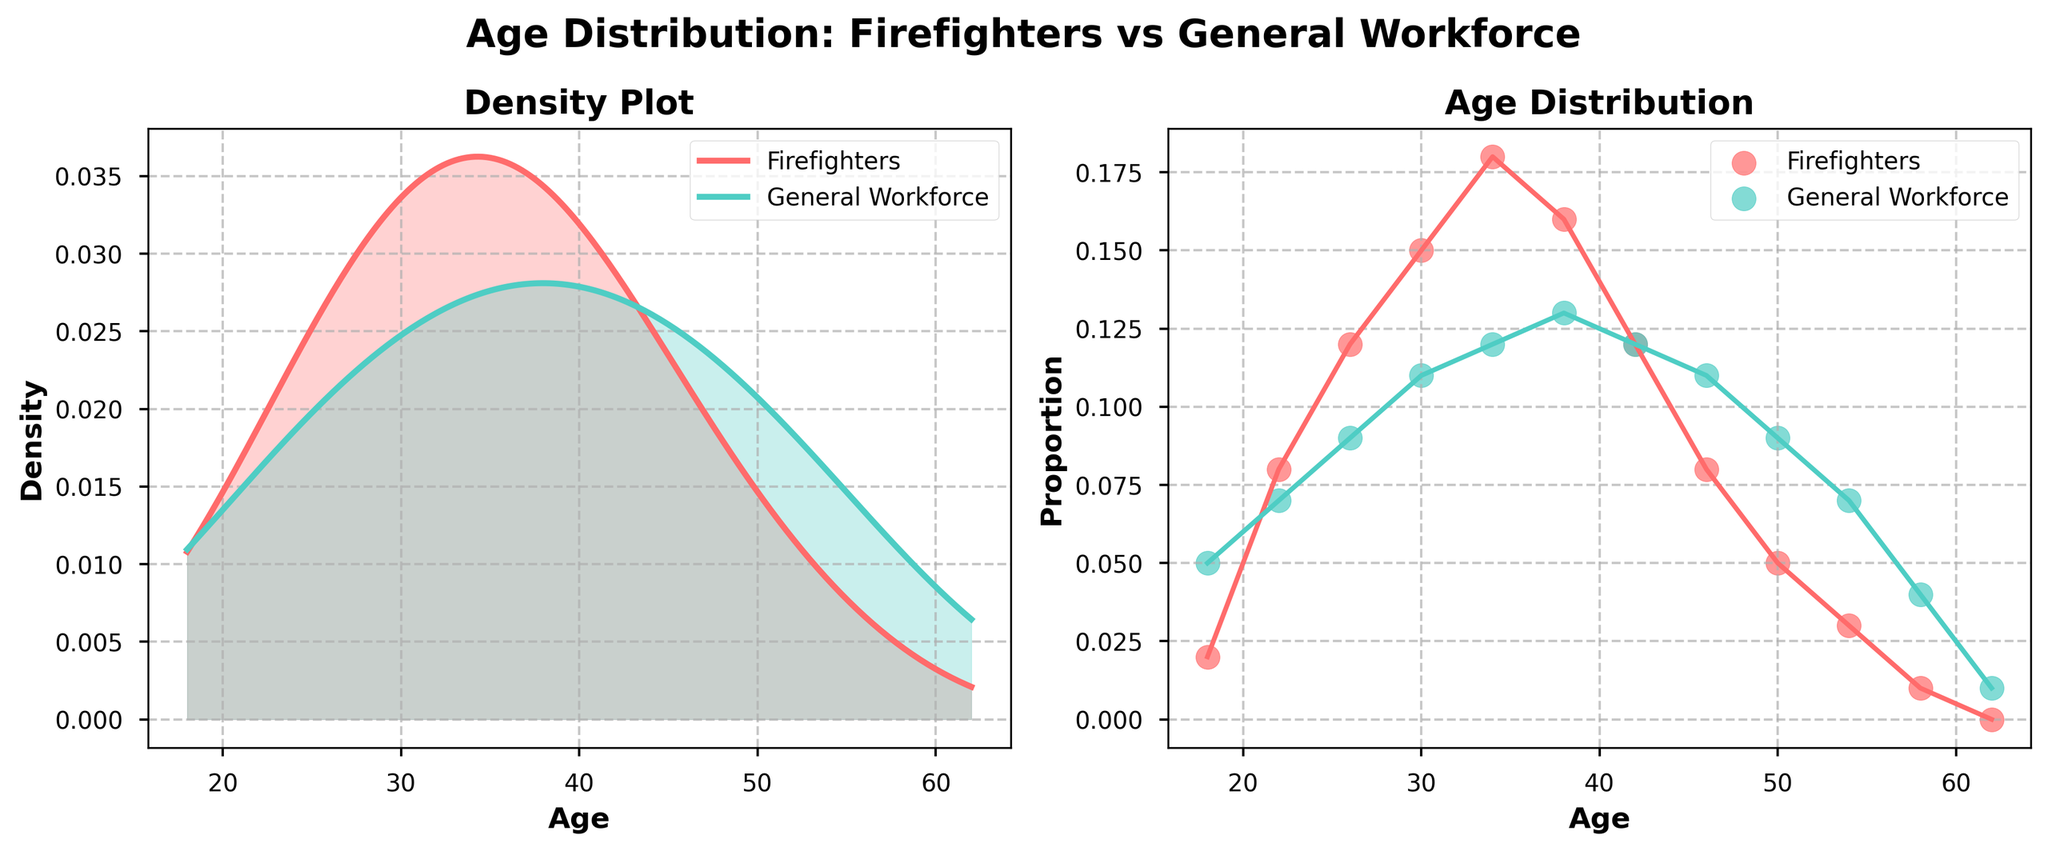what are the titles of the two subplots? The titles are located above each subplot. For the left subplot, look above the graph for the text, and for the right subplot, similarly look above the graph. First subplot title is "Density Plot". The second subplot title is "Age Distribution".
Answer: Density Plot and Age Distribution what is the age range covered by the plots? Check the x-axis of the plots. It shows the starting and ending age values. The age range starts at 18 and ends at 62, as indicated on the x-axis.
Answer: 18 to 62 which group shows a higher peak density in the density plot? Look at the height of the peaks in the left subplot. Compare both colored lines: the red line (Firefighters) and the teal line (General Workforce). The Firefighters line has the higher peak.
Answer: Firefighters how does the density of the general workforce change after age 38? In the left subplot, follow the teal line (General Workforce) from age 38 onwards. Observe if it rises or falls. The line starts to decline after age 38.
Answer: It decreases at what age is the proportion of firefighters equal to the proportion of the general workforce? In the right subplot, find where the red and teal points are at the same height (same proportion). This happens at age 42.
Answer: 42 which group has more representation at age 26? In the right subplot, compare the vertical positions of points for Firefighters and General Workforce at age 26. The red point (Firefighters) is higher than the teal point (General Workforce).
Answer: Firefighters how do the patterns in age distribution for firefighters compare to the general workforce? Observe both subplots for similarities and differences in the curves and dots. The Firefighters have a peak at a younger age compared to the General Workforce and then declines more rapidly as age increases.
Answer: Higher peak at younger ages and rapid decline for Firefighters what is the trend in the density of firefighters after age 34? Check the left subplot after age 34 and follow the red line (Firefighters) to see if it rises, stays flat, or falls. The density starts to fall after age 34.
Answer: It decreases what visual cues indicate differences between the two groups in the density plot? Identify different visual aspects such as line color, line height (density), and shaded areas in the left subplot. The red line for Firefighters is higher and more peaked than the teal line for General Workforce, which is more spread out.
Answer: Line color, line height, shaded areas 